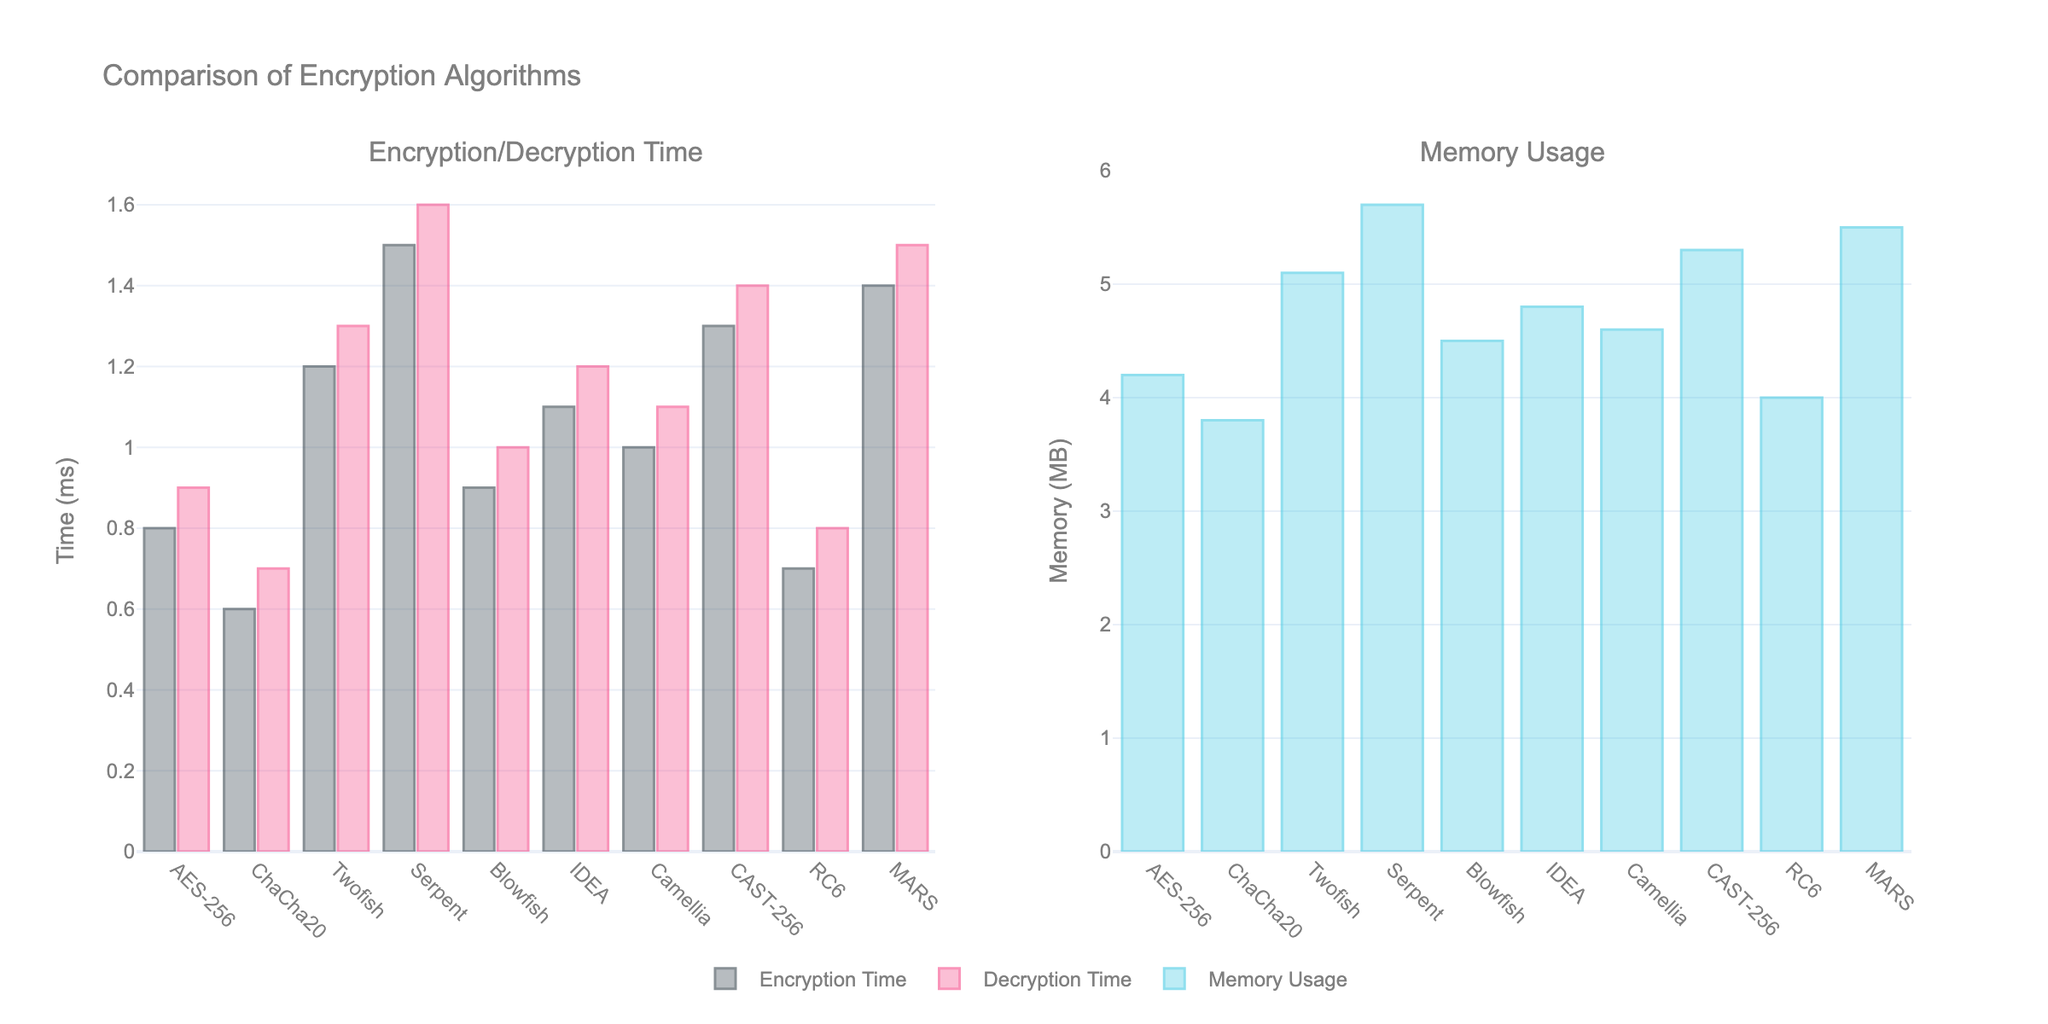Which algorithm has the shortest encryption time? The algorithm with the shortest encryption time can be identified by finding the bar with the smallest height in the encryption time graph. ChaCha20 has the shortest encryption time.
Answer: ChaCha20 Which algorithm uses the most memory? The algorithm with the most memory usage can be identified by finding the tallest bar in the memory usage graph. Serpent has the highest memory usage.
Answer: Serpent What is the total encryption time of AES-256 and RC6? Add the encryption times of AES-256 and RC6. AES-256 encryption time is 0.8 ms and RC6 encryption time is 0.7 ms, so the total is 0.8 + 0.7 = 1.5 ms.
Answer: 1.5 ms Which algorithm shows the longest decryption time? The algorithm with the longest decryption time can be determined by finding the tallest bar in the decryption time graph. Serpent has the longest decryption time.
Answer: Serpent What is the average memory usage across all algorithms? Sum the memory usage of all algorithms and divide by the number of algorithms. The total memory usage is (4.2 + 3.8 + 5.1 + 5.7 + 4.5 + 4.8 + 4.6 + 5.3 + 4.0 + 5.5) = 47.5 MB and there are 10 algorithms, so the average is 47.5 / 10 = 4.75 MB.
Answer: 4.75 MB How much more memory does Serpent use compared to ChaCha20? Subtract the memory usage of ChaCha20 from Serpent. Serpent uses 5.7 MB while ChaCha20 uses 3.8 MB, so 5.7 - 3.8 = 1.9 MB.
Answer: 1.9 MB Which algorithms have both encryption and decryption times less than 1 ms? Identify the bars where both encryption and decryption times are less than 1 ms. AES-256, ChaCha20, RC6, and Blowfish fit this criterion.
Answer: AES-256, ChaCha20, RC6, Blowfish Which algorithm has a higher decryption time than encryption time but less than 1.5 ms for both? Compare the encryption and decryption times for each algorithm and find those where decryption time is higher but both times are less than 1.5 ms. AES-256, ChaCha20, RC6, and Blowfish qualify but only Blowfish has a higher decryption time than encryption time.
Answer: Blowfish What is the difference in encryption time between the fastest and the slowest algorithm? Subtract the encryption time of the fastest algorithm (ChaCha20) from the encryption time of the slowest algorithm (Serpent). The difference is 1.5 ms - 0.6 ms = 0.9 ms.
Answer: 0.9 ms 